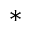Convert formula to latex. <formula><loc_0><loc_0><loc_500><loc_500>^ { * }</formula> 